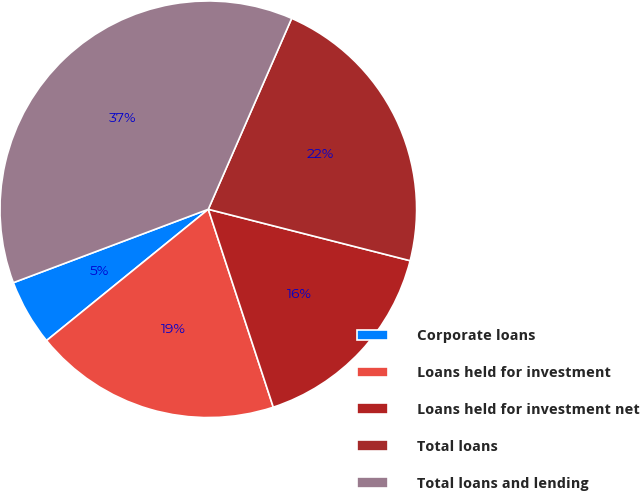<chart> <loc_0><loc_0><loc_500><loc_500><pie_chart><fcel>Corporate loans<fcel>Loans held for investment<fcel>Loans held for investment net<fcel>Total loans<fcel>Total loans and lending<nl><fcel>5.12%<fcel>19.2%<fcel>15.98%<fcel>22.42%<fcel>37.29%<nl></chart> 